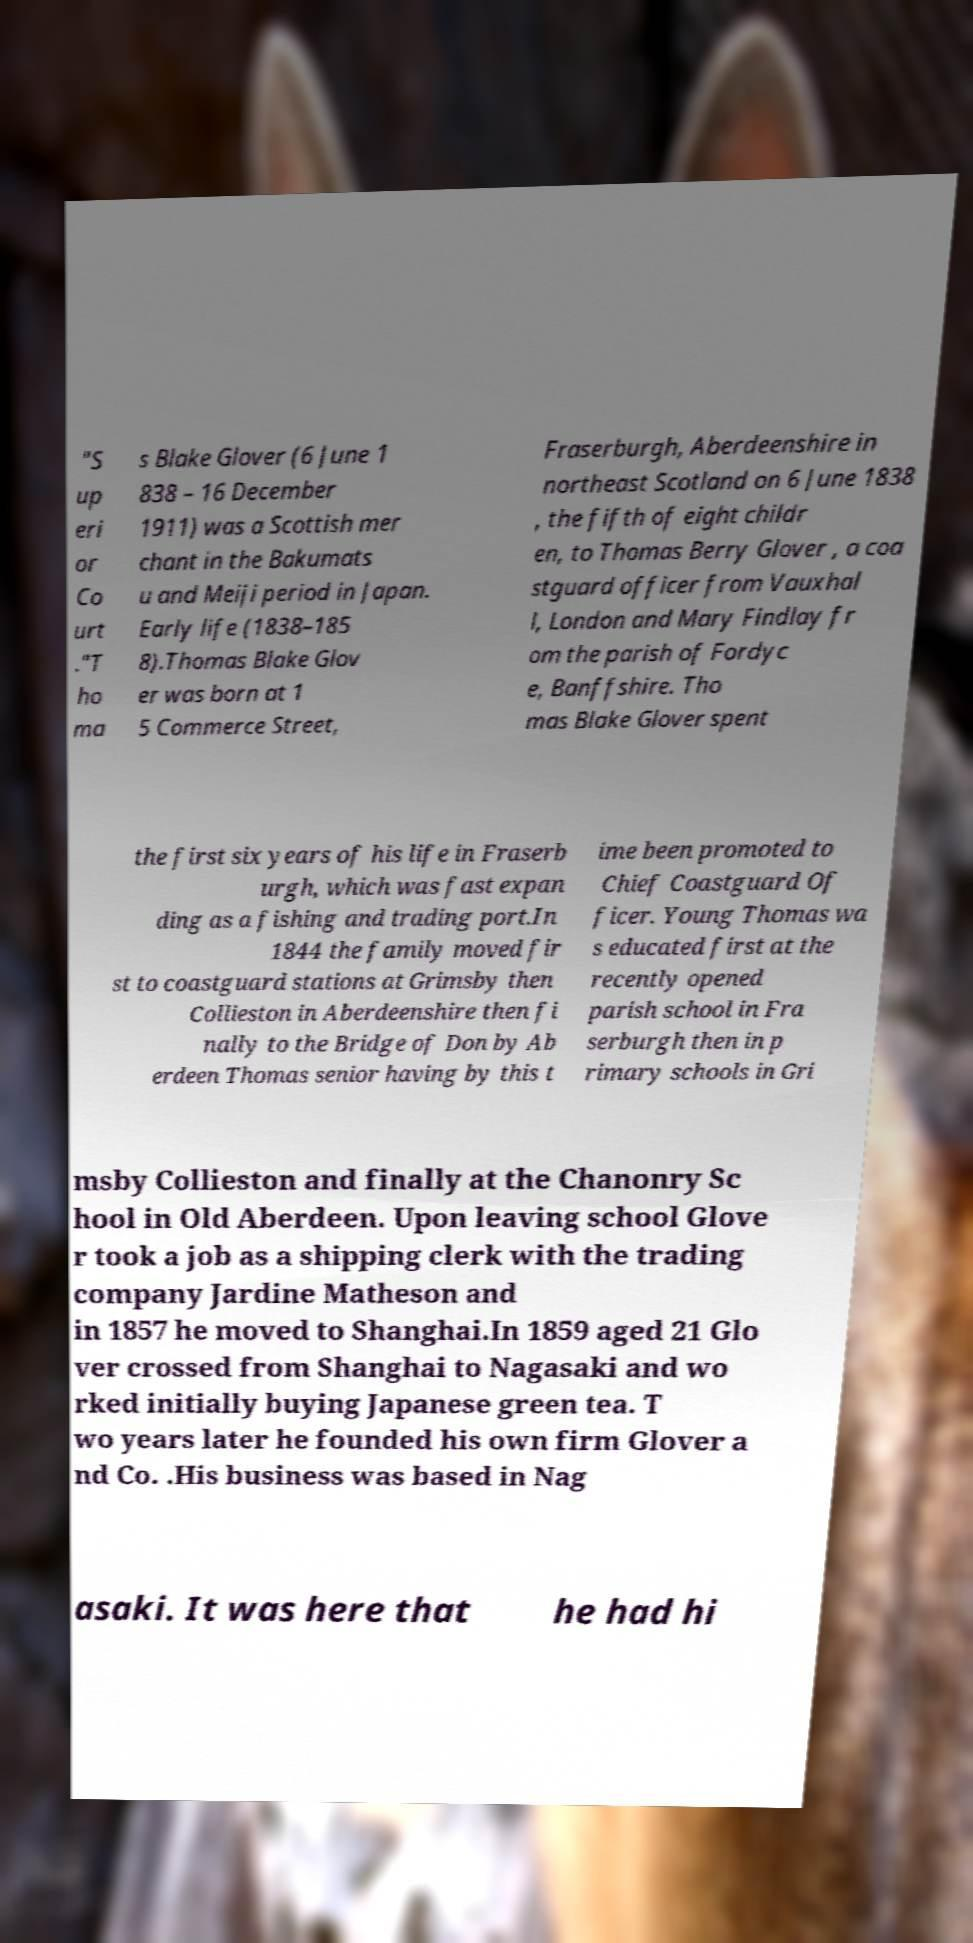Can you read and provide the text displayed in the image?This photo seems to have some interesting text. Can you extract and type it out for me? "S up eri or Co urt ."T ho ma s Blake Glover (6 June 1 838 – 16 December 1911) was a Scottish mer chant in the Bakumats u and Meiji period in Japan. Early life (1838–185 8).Thomas Blake Glov er was born at 1 5 Commerce Street, Fraserburgh, Aberdeenshire in northeast Scotland on 6 June 1838 , the fifth of eight childr en, to Thomas Berry Glover , a coa stguard officer from Vauxhal l, London and Mary Findlay fr om the parish of Fordyc e, Banffshire. Tho mas Blake Glover spent the first six years of his life in Fraserb urgh, which was fast expan ding as a fishing and trading port.In 1844 the family moved fir st to coastguard stations at Grimsby then Collieston in Aberdeenshire then fi nally to the Bridge of Don by Ab erdeen Thomas senior having by this t ime been promoted to Chief Coastguard Of ficer. Young Thomas wa s educated first at the recently opened parish school in Fra serburgh then in p rimary schools in Gri msby Collieston and finally at the Chanonry Sc hool in Old Aberdeen. Upon leaving school Glove r took a job as a shipping clerk with the trading company Jardine Matheson and in 1857 he moved to Shanghai.In 1859 aged 21 Glo ver crossed from Shanghai to Nagasaki and wo rked initially buying Japanese green tea. T wo years later he founded his own firm Glover a nd Co. .His business was based in Nag asaki. It was here that he had hi 